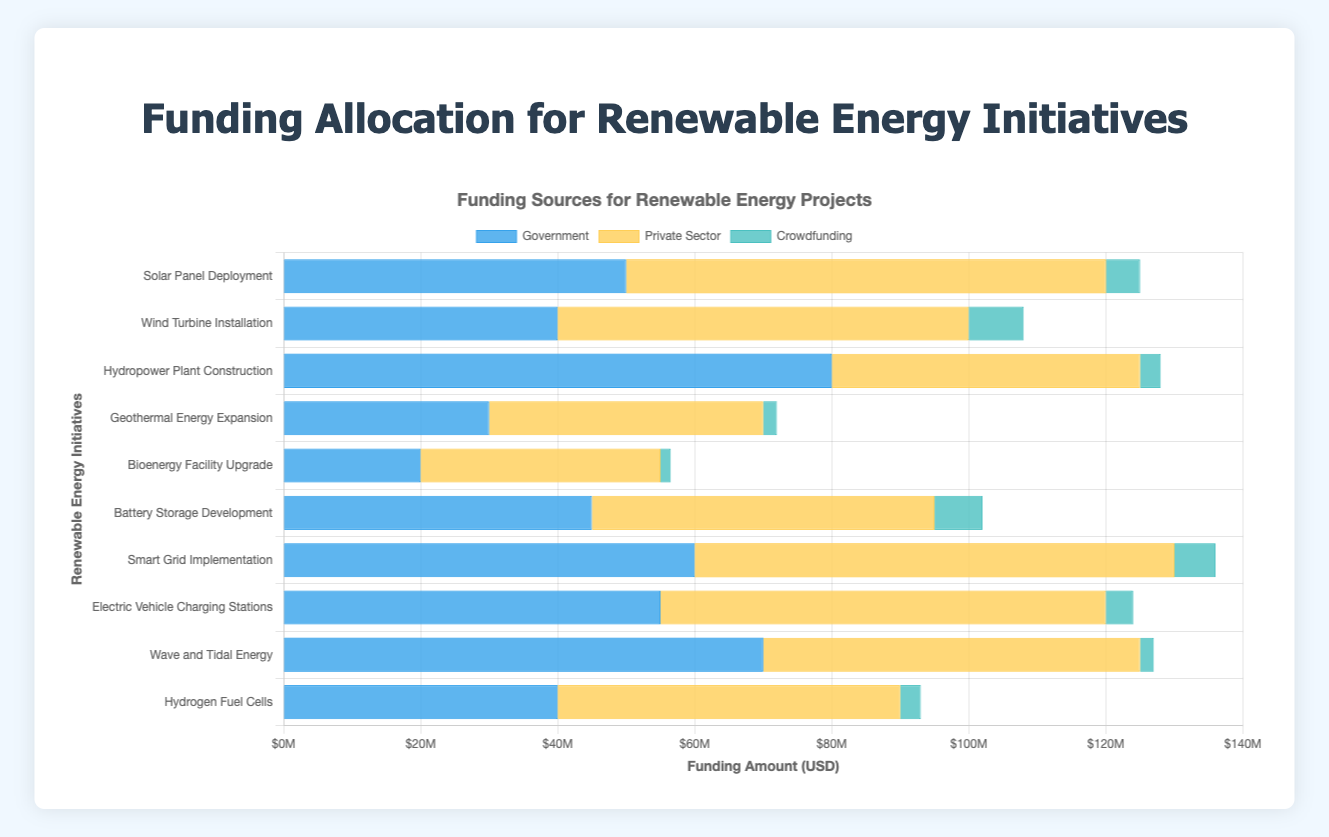What's the total funding allocated to the "Solar Panel Deployment" initiative? The Government allocated $50 million, the Private Sector allocated $70 million, and Crowdfunding allocated $5 million. Summing these amounts: 50 + 70 + 5 = $125 million.
Answer: $125 million Which initiative received the highest funding from the Private Sector? Reviewing the data, "Smart Grid Implementation" and "Solar Panel Deployment" both received $70 million from the Private Sector.
Answer: Smart Grid Implementation & Solar Panel Deployment How much more funding did the Government allocate to "Hydropower Plant Construction" than "Bioenergy Facility Upgrade"? The Government allocated $80 million to "Hydropower Plant Construction" and $20 million to "Bioenergy Facility Upgrade". The difference is 80 - 20 = $60 million.
Answer: $60 million What is the total amount of crowdfunding for all initiatives combined? Summing up the Crowdfunding amounts for each initiative: 5 + 8 + 3 + 2 + 1.5 + 7 + 6 + 4 + 2 + 3 = $41.5 million.
Answer: $41.5 million Which initiative received the least amount of total funding? Adding the funding from all sources for each initiative and identifying the smallest total: 
- Solar Panel Deployment: 50 + 70 + 5 = 125
- Wind Turbine Installation: 40 + 60 + 8 = 108
- Hydropower Plant Construction: 80 + 45 + 3 = 128
- Geothermal Energy Expansion: 30 + 40 + 2 = 72
- Bioenergy Facility Upgrade: 20 + 35 + 1.5 = 56.5
- Battery Storage Development: 45 + 50 + 7 = 102
- Smart Grid Implementation: 60 + 70 + 6 = 136
- Electric Vehicle Charging Stations: 55 + 65 + 4 = 124
- Wave and Tidal Energy: 70 + 55 + 2 = 127
- Hydrogen Fuel Cells: 40 + 50 + 3 = 93
 "Bioenergy Facility Upgrade" received the least amount at $56.5 million.
Answer: Bioenergy Facility Upgrade Which sources contribute more than $60 million in total to any initiative? Examining the contributions per source:
- Government: 
    - Solar Panel Deployment: $50M
    - Wind Turbine Installation: $40M
    - Hydropower Plant Construction: $80M
    - Geothermal Energy Expansion: $30M
    - Bioenergy Facility Upgrade: $20M
    - Battery Storage Development: $45M
    - Smart Grid Implementation: $60M
    - Electric Vehicle Charging Stations: $55M
    - Wave and Tidal Energy: $70M
    - Hydrogen Fuel Cells: $40M
- Private Sector:
    - Solar Panel Deployment: $70M
    - Wind Turbine Installation: $60M
    - Hydropower Plant Construction: $45M
    - Geothermal Energy Expansion: $40M
    - Bioenergy Facility Upgrade: $35M
    - Battery Storage Development: $50M
    - Smart Grid Implementation: $70M
    - Electric Vehicle Charging Stations: $65M
    - Wave and Tidal Energy: $55M
    - Hydrogen Fuel Cells: $50M
- Crowdfunding:
    - None of the initiatives have Crowdfunding over $60M.
 
"Government" for "Hydropower Plant Construction" and "Wave and Tidal Energy", "Private Sector" for "Solar Panel Deployment", "Smart Grid Implementation", and "Electric Vehicle Charging Stations".
Answer: Hydropower Plant Construction, Wave and Tidal Energy (Government); Smart Grid Implementation, Solar Panel Deployment, Electric Vehicle Charging Stations (Private Sector) Which initiative has the greatest funding variance between the sources? Calculating the variance (max-min) for each initiative:
- Solar Panel Deployment: 70 (Private Sector) - 5 (Crowdfunding) = 65
- Wind Turbine Installation: 60 (Private Sector) - 8 (Crowdfunding) = 52
- Hydropower Plant Construction: 80 (Government) - 3 (Crowdfunding) = 77
- Geothermal Energy Expansion: 40 (Private Sector) - 2 (Crowdfunding) = 38
- Bioenergy Facility Upgrade: 35 (Private Sector) - 1.5 (Crowdfunding) = 33.5
- Battery Storage Development: 50 (Private Sector) - 7 (Crowdfunding) = 43
- Smart Grid Implementation: 70 (Private Sector) - 6 (Crowdfunding) = 64
- Electric Vehicle Charging Stations: 65 (Private Sector) - 4 (Crowdfunding) = 61
- Wave and Tidal Energy: 70 (Government) - 2 (Crowdfunding) = 68
- Hydrogen Fuel Cells: 50 (Private Sector) - 3 (Crowdfunding) = 47
"Hydropower Plant Construction" has the greatest variance of $77 million.
Answer: Hydropower Plant Construction 